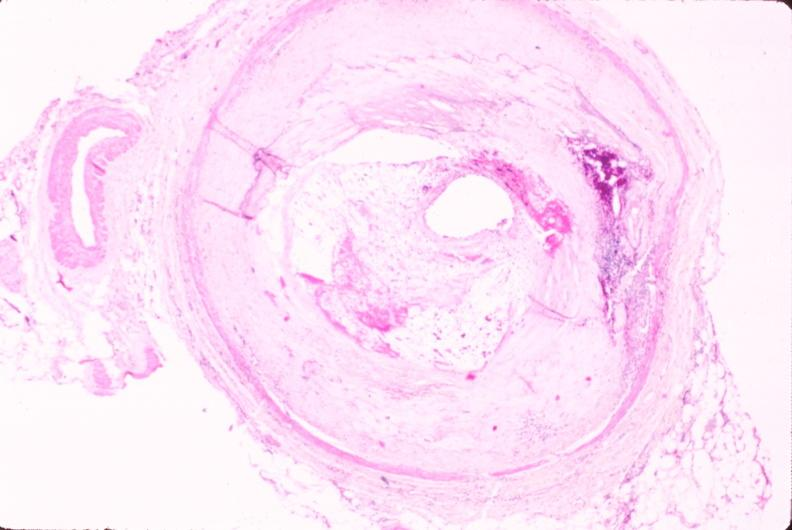where is this in?
Answer the question using a single word or phrase. In vasculature 